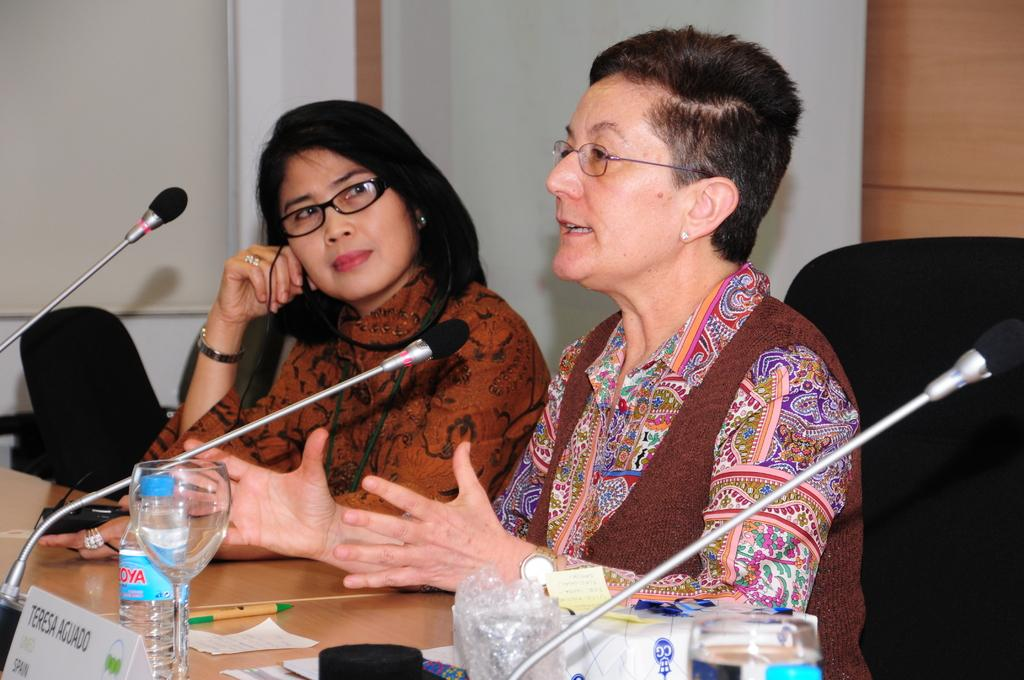How many people are in the image? There are two persons in the image. What are the persons doing in the image? The persons are sitting on chairs, and one of them is talking. What is present in the image besides the persons? There is a table in the image. What can be seen on the table? There are mice and other objects on the table. What type of spark can be seen coming from the mice on the table? There is no spark present in the image; it features two persons sitting on chairs, a table with mice and other objects, and one person talking. 